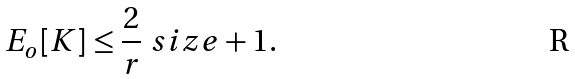Convert formula to latex. <formula><loc_0><loc_0><loc_500><loc_500>E _ { o } [ K ] \leq \frac { 2 } { r } \ s i z e + 1 .</formula> 